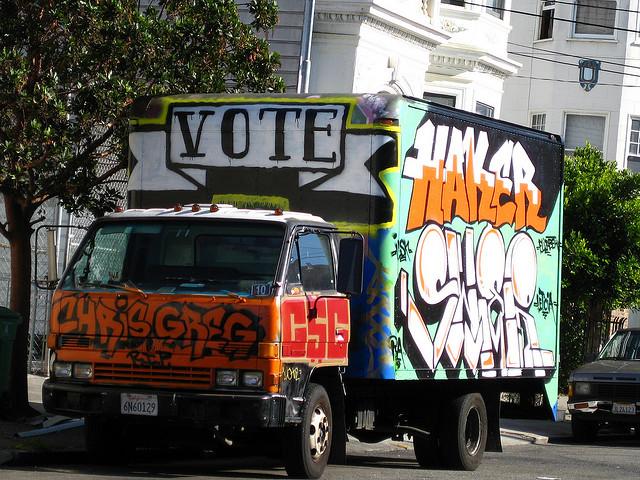Is there anyone in the truck?
Short answer required. No. Is the truck on the right side on the road?
Write a very short answer. Yes. Is this an American truck?
Give a very brief answer. Yes. What style of Font letters are designed all over the truck in the foreground?
Short answer required. Graffiti. 